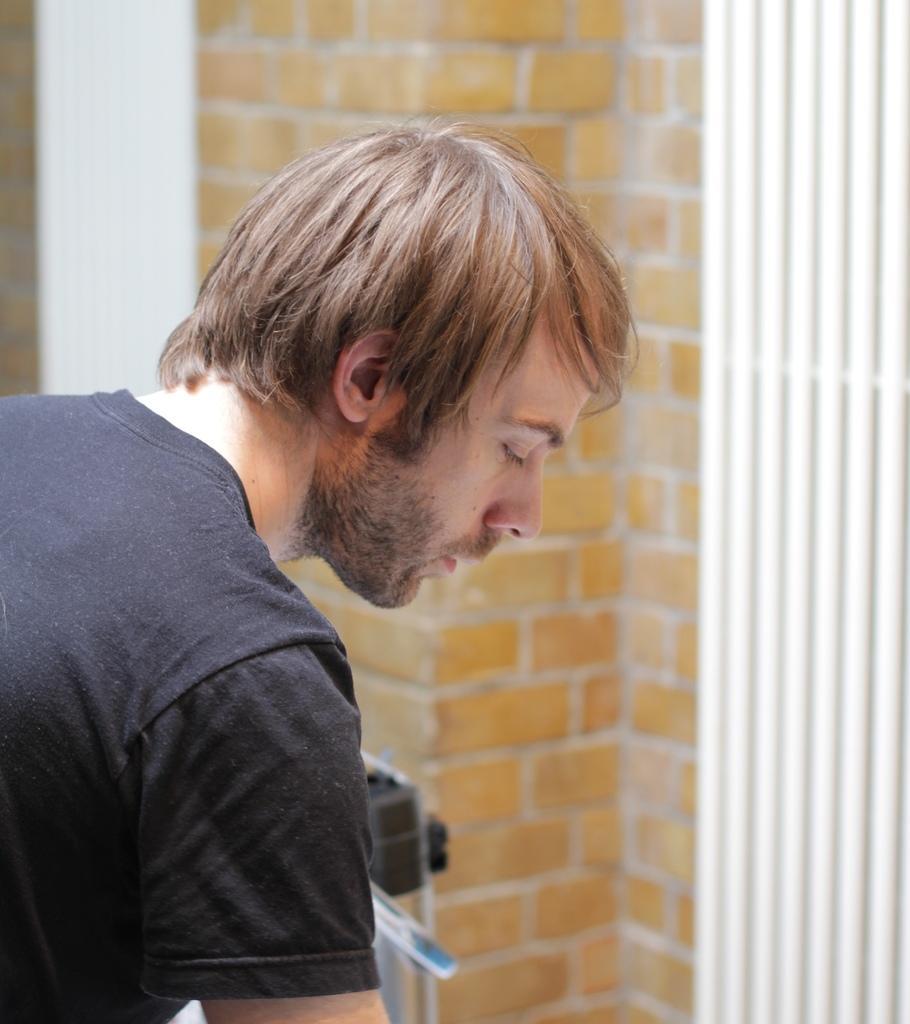Describe this image in one or two sentences. In this image, we can see a person. We can see the brick wall with some white color pipes. We can also see an object in front of the person. 